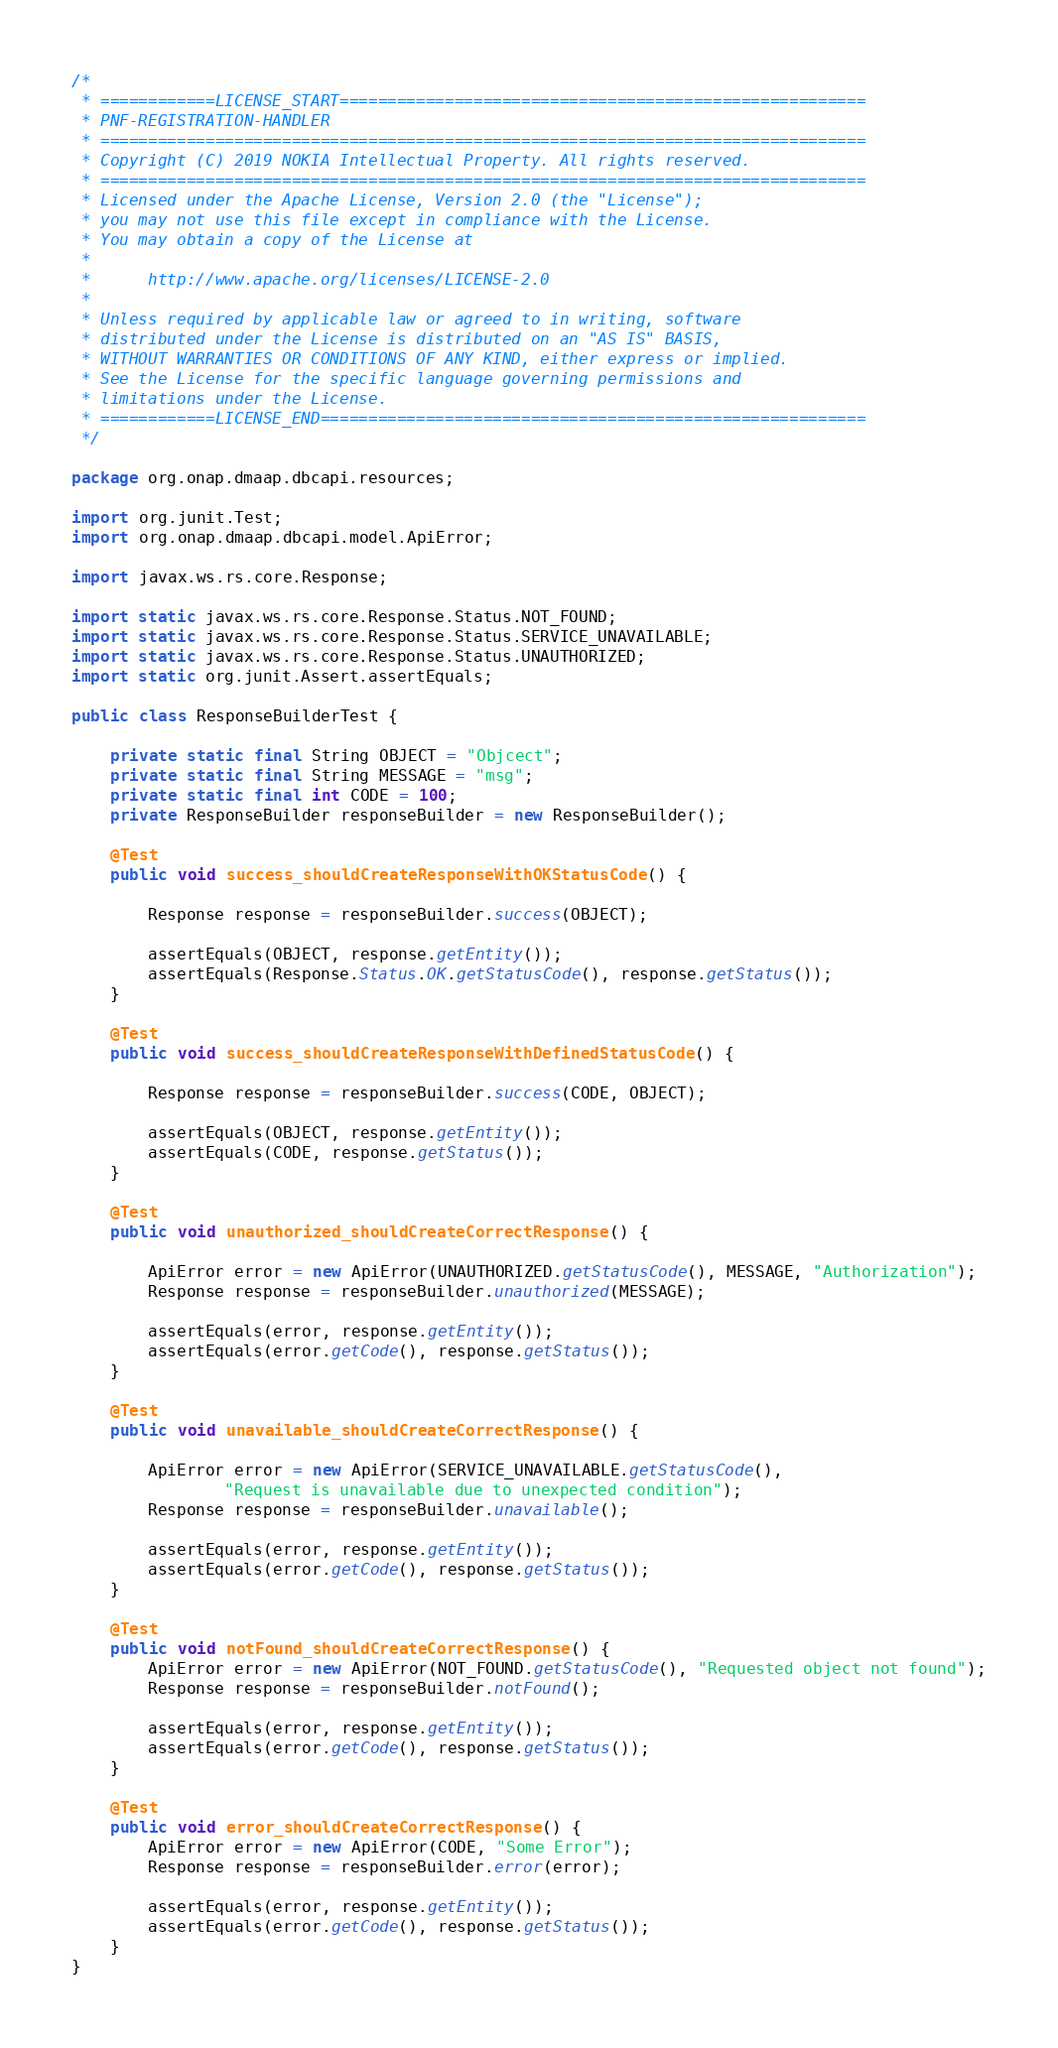<code> <loc_0><loc_0><loc_500><loc_500><_Java_>/*
 * ============LICENSE_START=======================================================
 * PNF-REGISTRATION-HANDLER
 * ================================================================================
 * Copyright (C) 2019 NOKIA Intellectual Property. All rights reserved.
 * ================================================================================
 * Licensed under the Apache License, Version 2.0 (the "License");
 * you may not use this file except in compliance with the License.
 * You may obtain a copy of the License at
 *
 *      http://www.apache.org/licenses/LICENSE-2.0
 *
 * Unless required by applicable law or agreed to in writing, software
 * distributed under the License is distributed on an "AS IS" BASIS,
 * WITHOUT WARRANTIES OR CONDITIONS OF ANY KIND, either express or implied.
 * See the License for the specific language governing permissions and
 * limitations under the License.
 * ============LICENSE_END=========================================================
 */

package org.onap.dmaap.dbcapi.resources;

import org.junit.Test;
import org.onap.dmaap.dbcapi.model.ApiError;

import javax.ws.rs.core.Response;

import static javax.ws.rs.core.Response.Status.NOT_FOUND;
import static javax.ws.rs.core.Response.Status.SERVICE_UNAVAILABLE;
import static javax.ws.rs.core.Response.Status.UNAUTHORIZED;
import static org.junit.Assert.assertEquals;

public class ResponseBuilderTest {

    private static final String OBJECT = "Objcect";
    private static final String MESSAGE = "msg";
    private static final int CODE = 100;
    private ResponseBuilder responseBuilder = new ResponseBuilder();

    @Test
    public void success_shouldCreateResponseWithOKStatusCode() {

        Response response = responseBuilder.success(OBJECT);

        assertEquals(OBJECT, response.getEntity());
        assertEquals(Response.Status.OK.getStatusCode(), response.getStatus());
    }

    @Test
    public void success_shouldCreateResponseWithDefinedStatusCode() {

        Response response = responseBuilder.success(CODE, OBJECT);

        assertEquals(OBJECT, response.getEntity());
        assertEquals(CODE, response.getStatus());
    }

    @Test
    public void unauthorized_shouldCreateCorrectResponse() {

        ApiError error = new ApiError(UNAUTHORIZED.getStatusCode(), MESSAGE, "Authorization");
        Response response = responseBuilder.unauthorized(MESSAGE);

        assertEquals(error, response.getEntity());
        assertEquals(error.getCode(), response.getStatus());
    }

    @Test
    public void unavailable_shouldCreateCorrectResponse() {

        ApiError error = new ApiError(SERVICE_UNAVAILABLE.getStatusCode(),
                "Request is unavailable due to unexpected condition");
        Response response = responseBuilder.unavailable();

        assertEquals(error, response.getEntity());
        assertEquals(error.getCode(), response.getStatus());
    }

    @Test
    public void notFound_shouldCreateCorrectResponse() {
        ApiError error = new ApiError(NOT_FOUND.getStatusCode(), "Requested object not found");
        Response response = responseBuilder.notFound();

        assertEquals(error, response.getEntity());
        assertEquals(error.getCode(), response.getStatus());
    }

    @Test
    public void error_shouldCreateCorrectResponse() {
        ApiError error = new ApiError(CODE, "Some Error");
        Response response = responseBuilder.error(error);

        assertEquals(error, response.getEntity());
        assertEquals(error.getCode(), response.getStatus());
    }
}</code> 